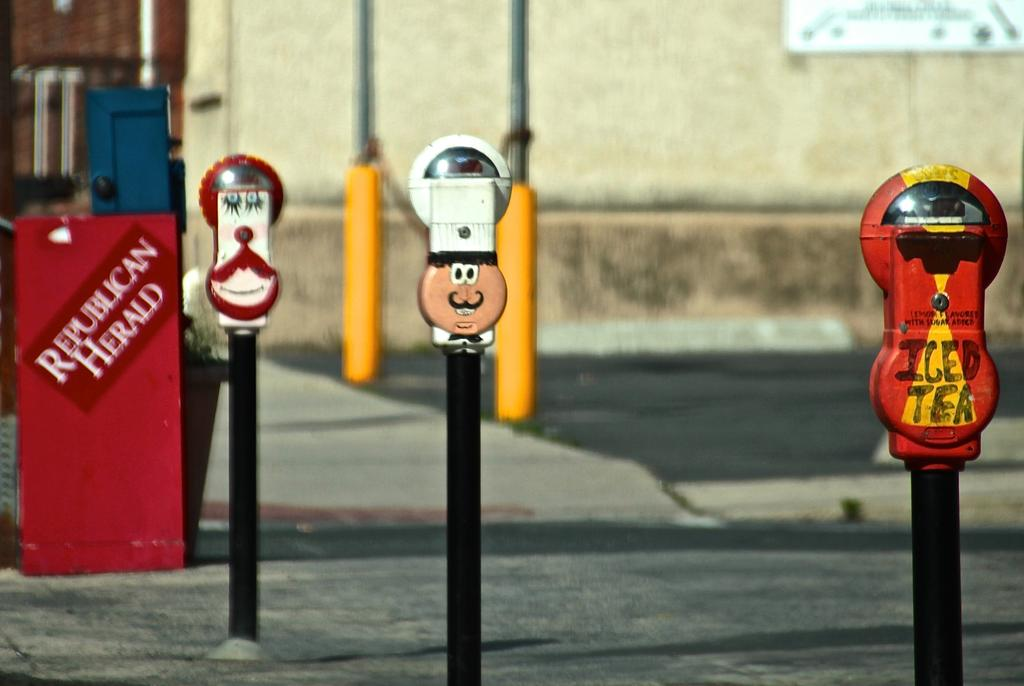<image>
Summarize the visual content of the image. three colorfully painted parking meters, the front one has iced tea written on it and there is a red republican herald paperbox in the back 